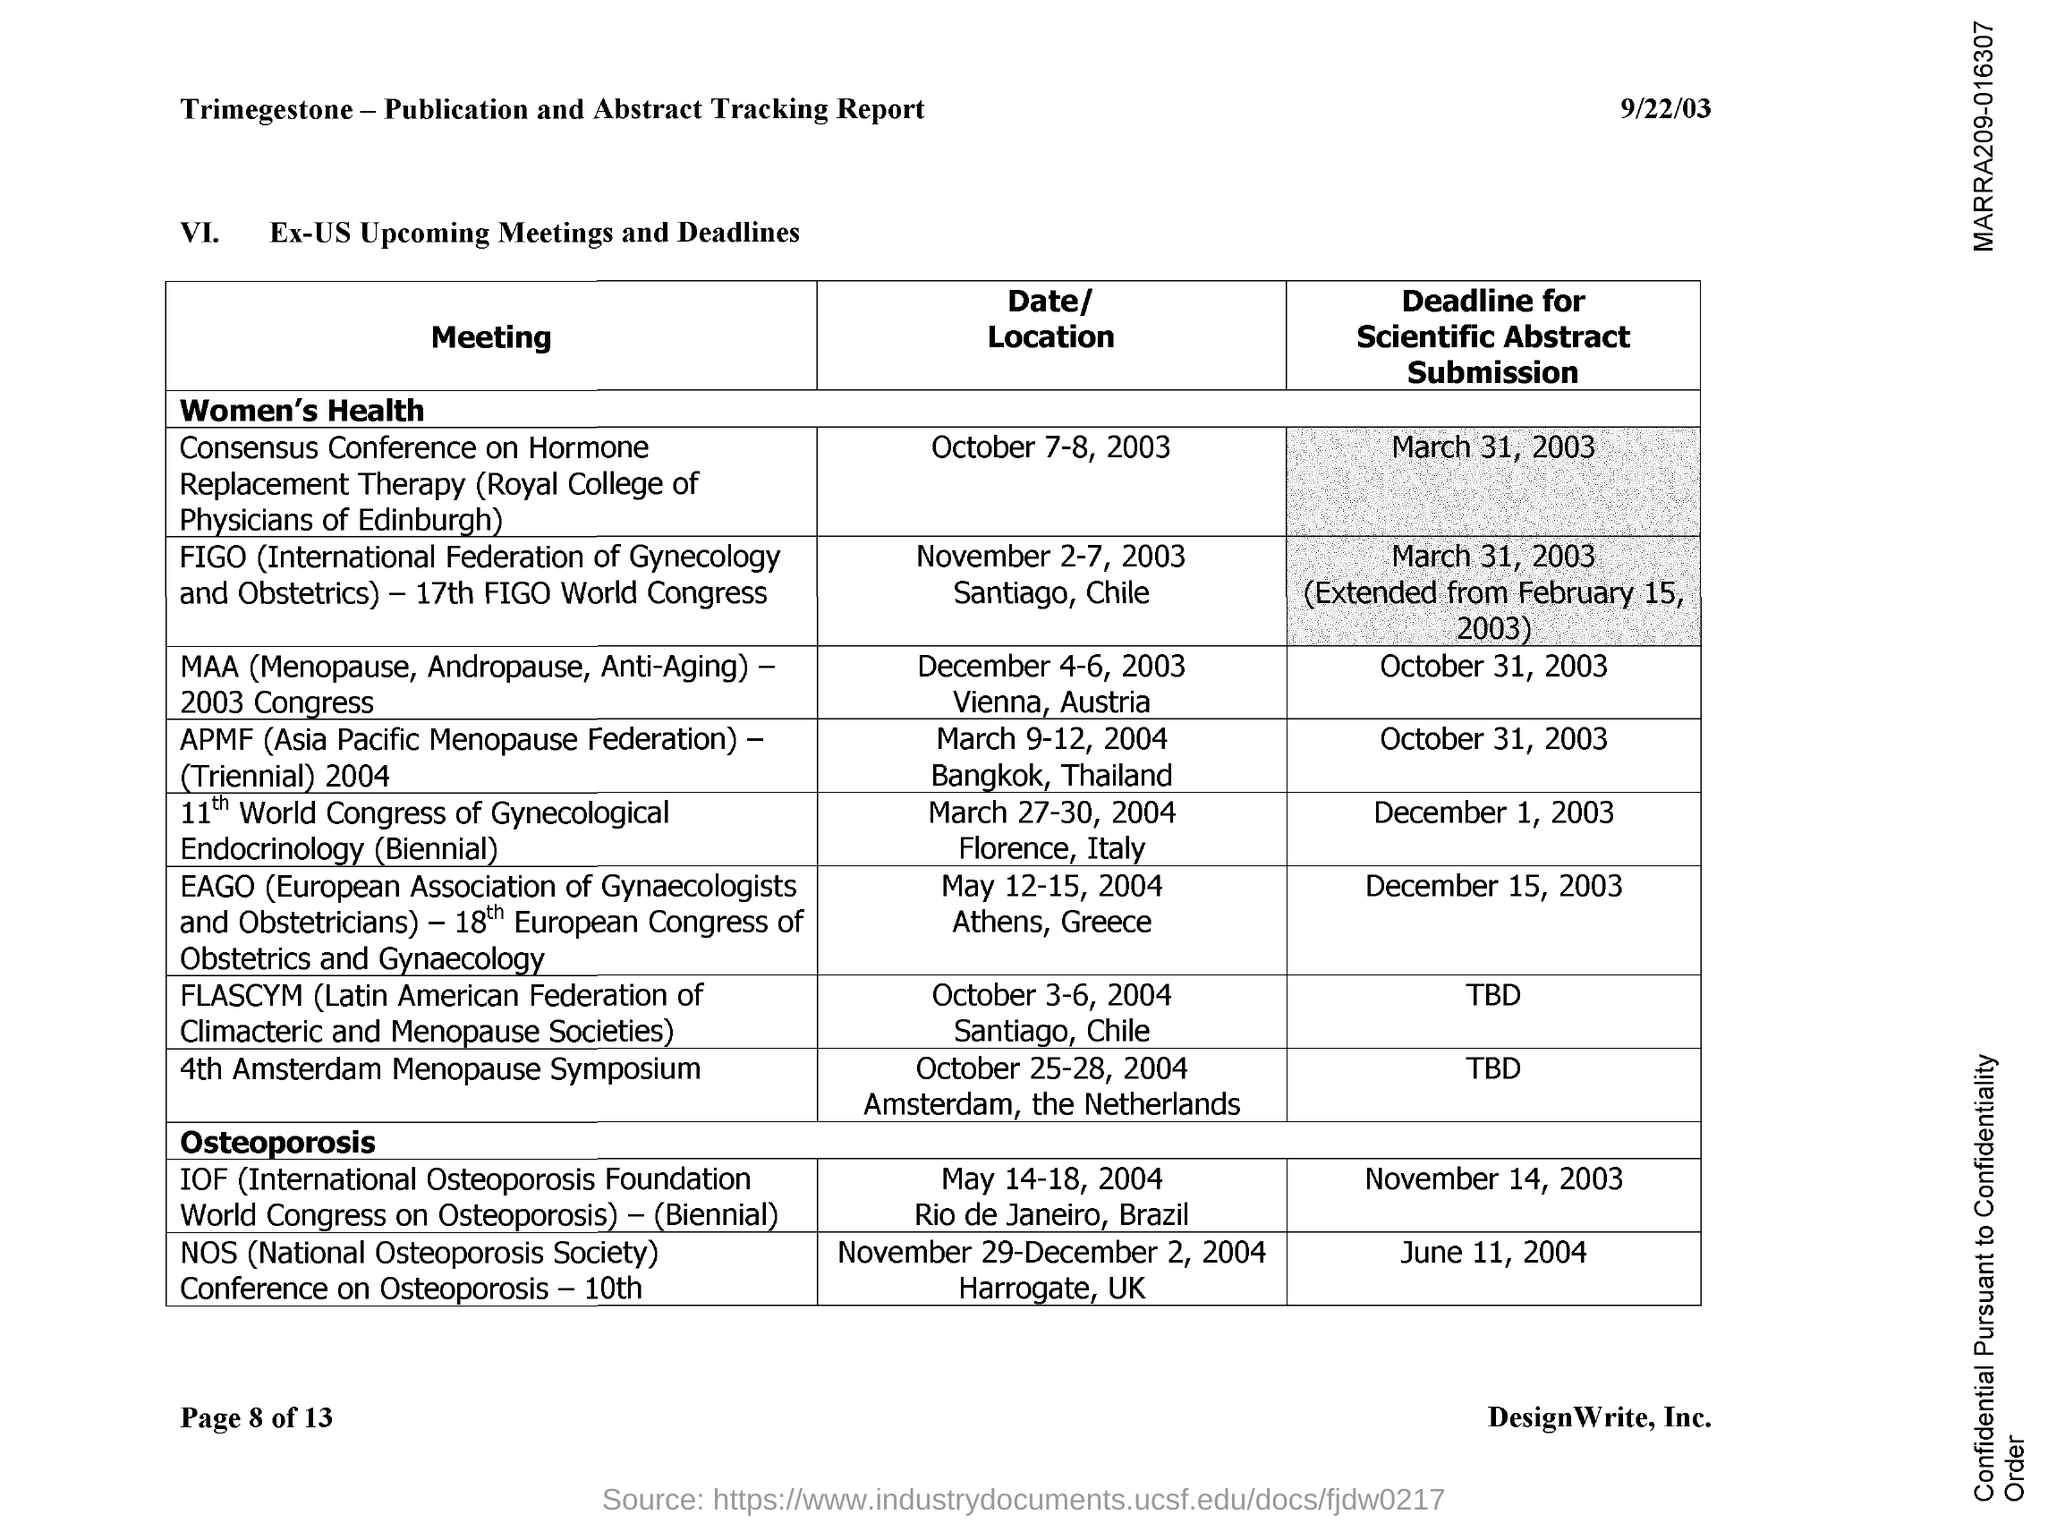Outline some significant characteristics in this image. The full form of APMF is the Asia Pacific Menopause Federation. The full form of NOS is the National Osteoporosis Society. 